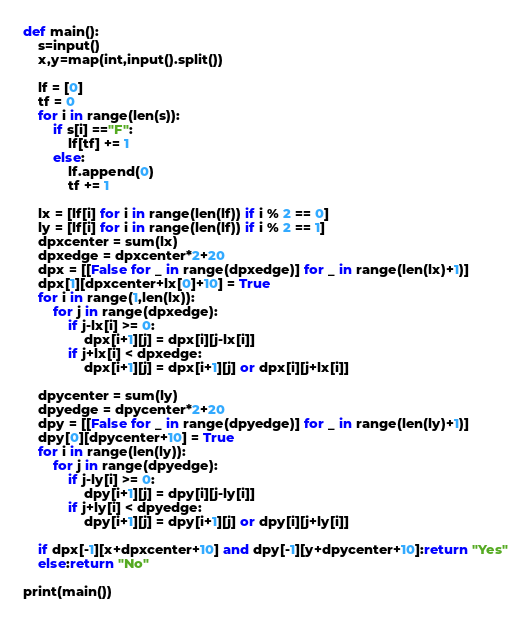Convert code to text. <code><loc_0><loc_0><loc_500><loc_500><_Python_>def main():
    s=input()
    x,y=map(int,input().split())

    lf = [0]
    tf = 0
    for i in range(len(s)):
        if s[i] =="F":
            lf[tf] += 1
        else:
            lf.append(0)
            tf += 1

    lx = [lf[i] for i in range(len(lf)) if i % 2 == 0]
    ly = [lf[i] for i in range(len(lf)) if i % 2 == 1]
    dpxcenter = sum(lx)
    dpxedge = dpxcenter*2+20
    dpx = [[False for _ in range(dpxedge)] for _ in range(len(lx)+1)]
    dpx[1][dpxcenter+lx[0]+10] = True
    for i in range(1,len(lx)):
        for j in range(dpxedge):
            if j-lx[i] >= 0:
                dpx[i+1][j] = dpx[i][j-lx[i]]
            if j+lx[i] < dpxedge:
                dpx[i+1][j] = dpx[i+1][j] or dpx[i][j+lx[i]]

    dpycenter = sum(ly)
    dpyedge = dpycenter*2+20
    dpy = [[False for _ in range(dpyedge)] for _ in range(len(ly)+1)]
    dpy[0][dpycenter+10] = True
    for i in range(len(ly)):
        for j in range(dpyedge):
            if j-ly[i] >= 0:
                dpy[i+1][j] = dpy[i][j-ly[i]]
            if j+ly[i] < dpyedge:
                dpy[i+1][j] = dpy[i+1][j] or dpy[i][j+ly[i]]

    if dpx[-1][x+dpxcenter+10] and dpy[-1][y+dpycenter+10]:return "Yes"
    else:return "No"

print(main())</code> 